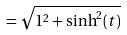<formula> <loc_0><loc_0><loc_500><loc_500>= \sqrt { 1 ^ { 2 } + \sinh ^ { 2 } ( t ) }</formula> 